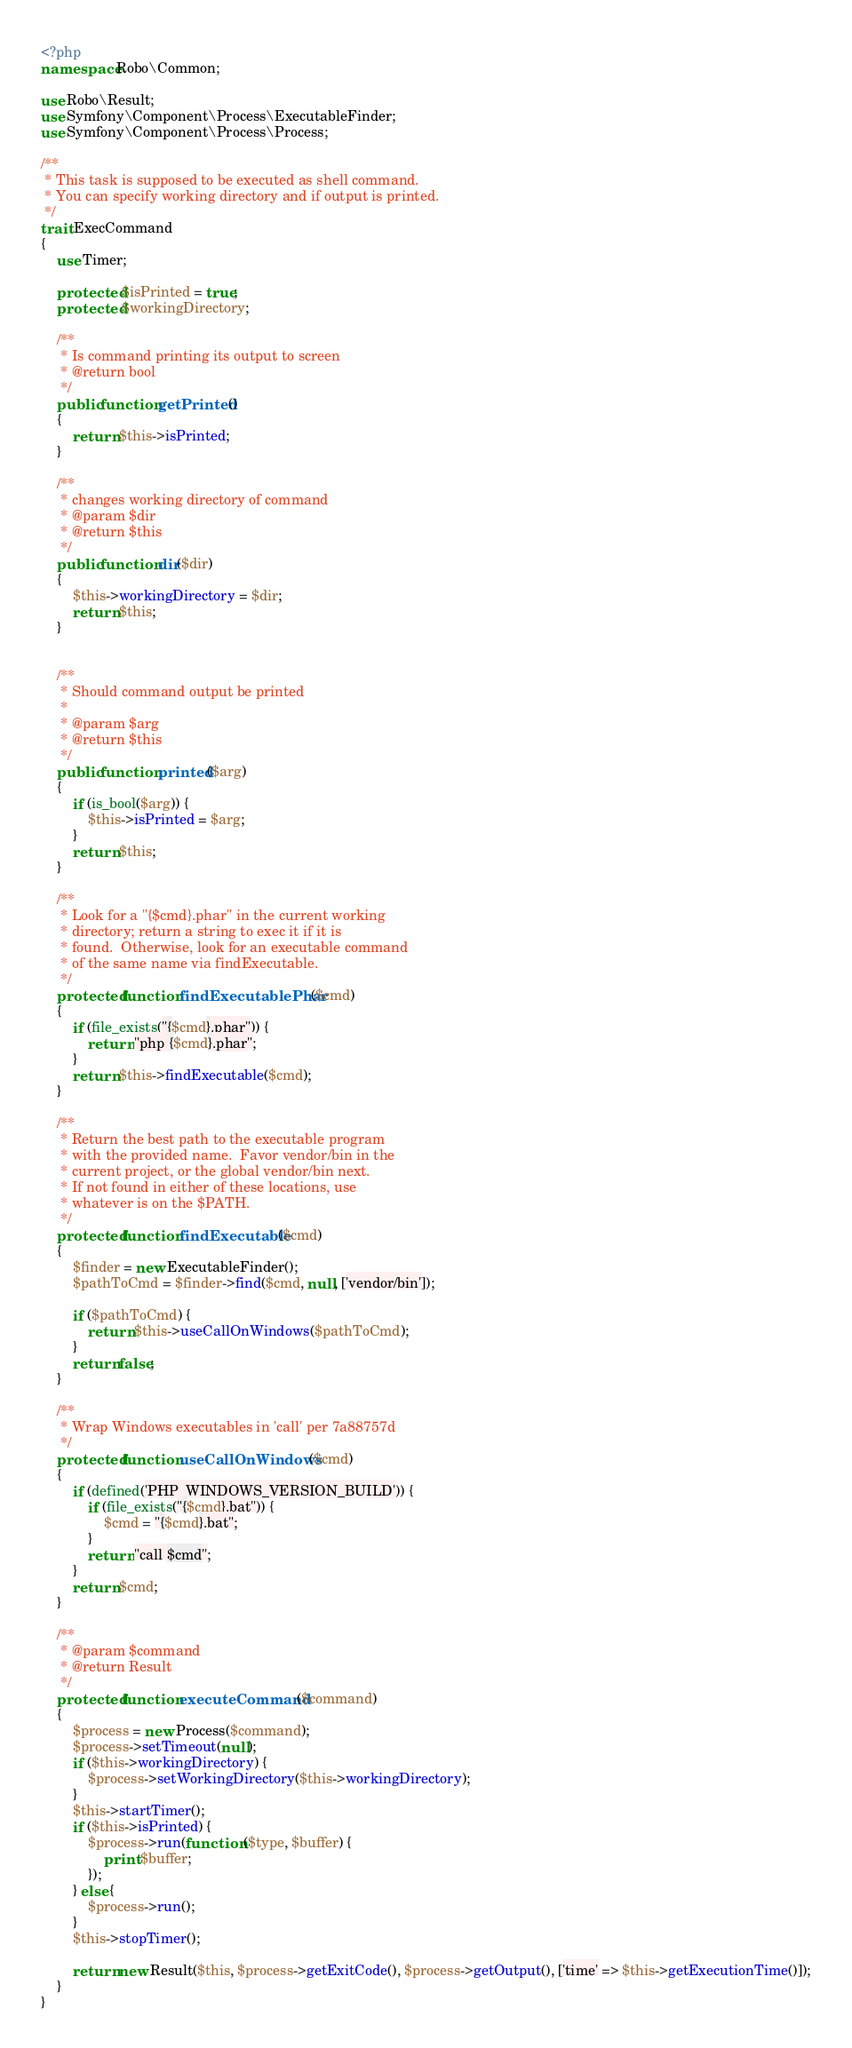Convert code to text. <code><loc_0><loc_0><loc_500><loc_500><_PHP_><?php
namespace Robo\Common;

use Robo\Result;
use Symfony\Component\Process\ExecutableFinder;
use Symfony\Component\Process\Process;

/**
 * This task is supposed to be executed as shell command.
 * You can specify working directory and if output is printed.
 */
trait ExecCommand
{
    use Timer;

    protected $isPrinted = true;
    protected $workingDirectory;

    /**
     * Is command printing its output to screen
     * @return bool
     */
    public function getPrinted()
    {
        return $this->isPrinted;
    }

    /**
     * changes working directory of command
     * @param $dir
     * @return $this
     */
    public function dir($dir)
    {
        $this->workingDirectory = $dir;
        return $this;
    }


    /**
     * Should command output be printed
     *
     * @param $arg
     * @return $this
     */
    public function printed($arg)
    {
        if (is_bool($arg)) {
            $this->isPrinted = $arg;
        }
        return $this;
    }

    /**
     * Look for a "{$cmd}.phar" in the current working
     * directory; return a string to exec it if it is
     * found.  Otherwise, look for an executable command
     * of the same name via findExecutable.
     */
    protected function findExecutablePhar($cmd)
    {
        if (file_exists("{$cmd}.phar")) {
            return "php {$cmd}.phar";
        }
        return $this->findExecutable($cmd);
    }

    /**
     * Return the best path to the executable program
     * with the provided name.  Favor vendor/bin in the
     * current project, or the global vendor/bin next.
     * If not found in either of these locations, use
     * whatever is on the $PATH.
     */
    protected function findExecutable($cmd)
    {
        $finder = new ExecutableFinder();
        $pathToCmd = $finder->find($cmd, null, ['vendor/bin']);

        if ($pathToCmd) {
            return $this->useCallOnWindows($pathToCmd);
        }
        return false;
    }

    /**
     * Wrap Windows executables in 'call' per 7a88757d
     */
    protected function useCallOnWindows($cmd)
    {
        if (defined('PHP_WINDOWS_VERSION_BUILD')) {
            if (file_exists("{$cmd}.bat")) {
                $cmd = "{$cmd}.bat";
            }
            return "call $cmd";
        }
        return $cmd;
    }

    /**
     * @param $command
     * @return Result
     */
    protected function executeCommand($command)
    {
        $process = new Process($command);
        $process->setTimeout(null);
        if ($this->workingDirectory) {
            $process->setWorkingDirectory($this->workingDirectory);
        }
        $this->startTimer();
        if ($this->isPrinted) {
            $process->run(function ($type, $buffer) {
                print $buffer;
            });
        } else {
            $process->run();
        }
        $this->stopTimer();

        return new Result($this, $process->getExitCode(), $process->getOutput(), ['time' => $this->getExecutionTime()]);
    }
}
</code> 